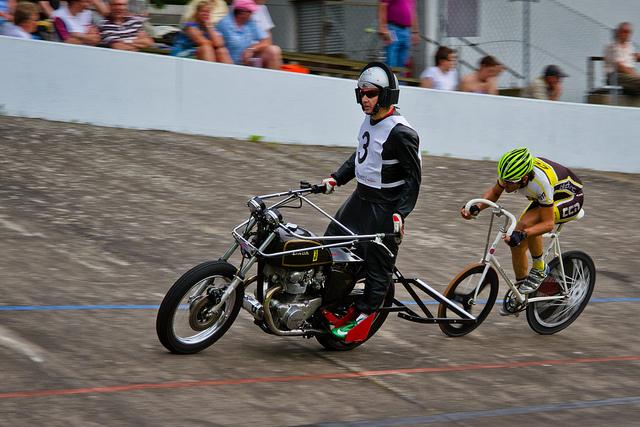What number of men are riding motorcycles?
Write a very short answer. 1. Does the second cyclist look like they are training for competition?
Concise answer only. Yes. Are all of these people wearing shorts?
Quick response, please. No. How many bikes are in the photo?
Answer briefly. 2. Are the two bikes the same general type?
Concise answer only. No. 